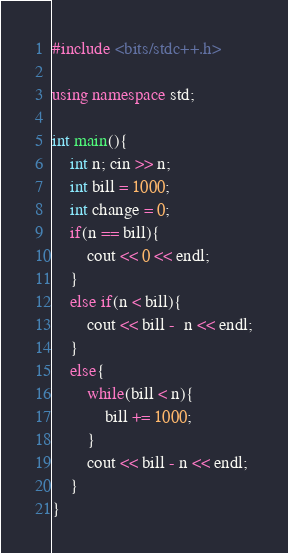<code> <loc_0><loc_0><loc_500><loc_500><_C++_>#include <bits/stdc++.h>

using namespace std;

int main(){
	int n; cin >> n;
	int bill = 1000;
	int change = 0;
	if(n == bill){
		cout << 0 << endl;
	}
	else if(n < bill){
		cout << bill -  n << endl;
	}
	else{
		while(bill < n){
			bill += 1000;
		}
		cout << bill - n << endl;
	}
}
</code> 